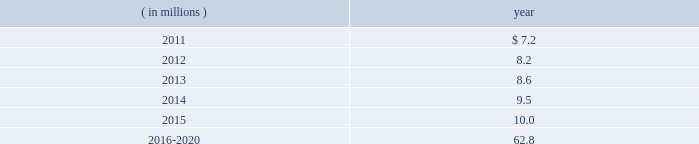The company expects to amortize $ 1.7 million of actuarial loss from accumulated other comprehensive income ( loss ) into net periodic benefit costs in 2011 .
At december 31 , 2010 , anticipated benefit payments from the plan in future years are as follows: .
Savings plans .
Cme maintains a defined contribution savings plan pursuant to section 401 ( k ) of the internal revenue code , whereby all u.s .
Employees are participants and have the option to contribute to this plan .
Cme matches employee contributions up to 3% ( 3 % ) of the employee 2019s base salary and may make additional discretionary contributions of up to 2% ( 2 % ) of base salary .
In addition , certain cme london-based employees are eligible to participate in a defined contribution plan .
For cme london-based employees , the plan provides for company contributions of 10% ( 10 % ) of earnings and does not have any vesting requirements .
Salary and cash bonuses paid are included in the definition of earnings .
Aggregate expense for all of the defined contribution savings plans amounted to $ 6.3 million , $ 5.2 million and $ 5.8 million in 2010 , 2009 and 2008 , respectively .
Cme non-qualified plans .
Cme maintains non-qualified plans , under which participants may make assumed investment choices with respect to amounts contributed on their behalf .
Although not required to do so , cme invests such contributions in assets that mirror the assumed investment choices .
The balances in these plans are subject to the claims of general creditors of the exchange and totaled $ 28.8 million and $ 23.4 million at december 31 , 2010 and 2009 , respectively .
Although the value of the plans is recorded as an asset in the consolidated balance sheets , there is an equal and offsetting liability .
The investment results of these plans have no impact on net income as the investment results are recorded in equal amounts to both investment income and compensation and benefits expense .
Supplemental savings plan 2014cme maintains a supplemental plan to provide benefits for employees who have been impacted by statutory limits under the provisions of the qualified pension and savings plan .
All cme employees hired prior to january 1 , 2007 are immediately vested in their supplemental plan benefits .
All cme employees hired on or after january 1 , 2007 are subject to the vesting requirements of the underlying qualified plans .
Total expense for the supplemental plan was $ 0.9 million , $ 0.7 million and $ 1.3 million for 2010 , 2009 and 2008 , respectively .
Deferred compensation plan 2014a deferred compensation plan is maintained by cme , under which eligible officers and members of the board of directors may contribute a percentage of their compensation and defer income taxes thereon until the time of distribution .
Nymexmembers 2019 retirement plan and benefits .
Nymex maintained a retirement and benefit plan under the commodities exchange , inc .
( comex ) members 2019 recognition and retention plan ( mrrp ) .
This plan provides benefits to certain members of the comex division based on long-term membership , and participation is limited to individuals who were comex division members prior to nymex 2019s acquisition of comex in 1994 .
No new participants were permitted into the plan after the date of this acquisition .
Under the terms of the mrrp , the company is required to fund the plan with a minimum annual contribution of $ 0.4 million until it is fully funded .
All benefits to be paid under the mrrp are based on reasonable actuarial assumptions which are based upon the amounts that are available and are expected to be available to pay benefits .
Total contributions to the plan were $ 0.8 million for each of 2010 , 2009 and for the period august 23 through december 31 , 2008 .
At december 31 , 2010 and 2009 , the total obligation for the mrrp totaled $ 20.7 million and $ 20.5 million .
What was the average 2010 and 2009 total liability for the mrrp , in millions? 
Computations: ((20.5 + 20.7) / 2)
Answer: 20.6. 